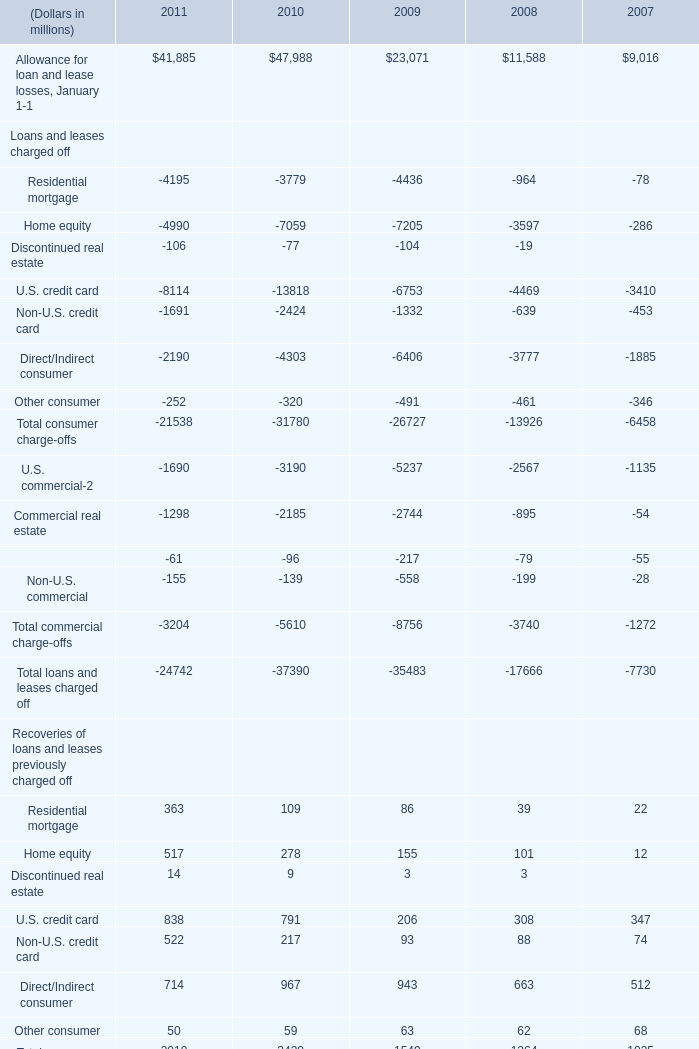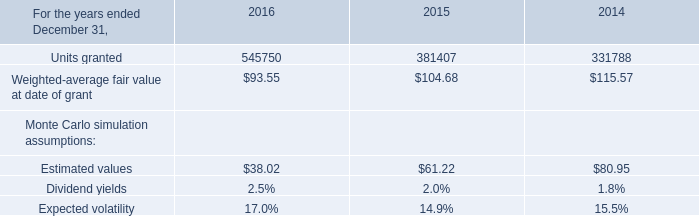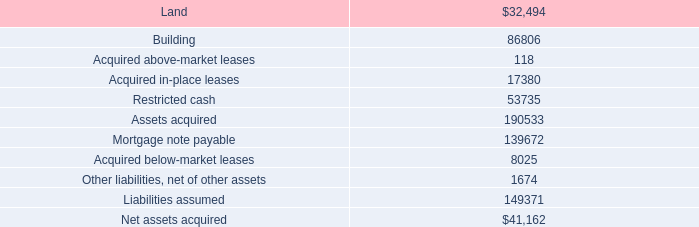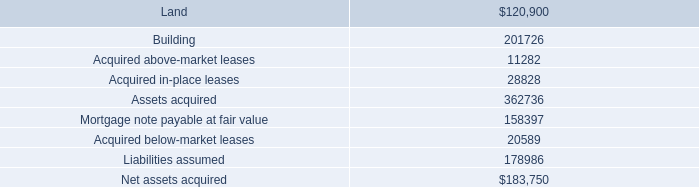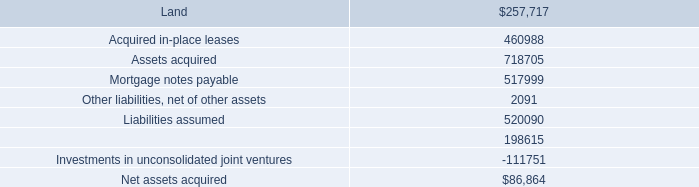What's the average of commercial recoveries in 2011? (in millions) 
Computations: ((((500 + 351) + 37) + 3) / 4)
Answer: 222.75. 